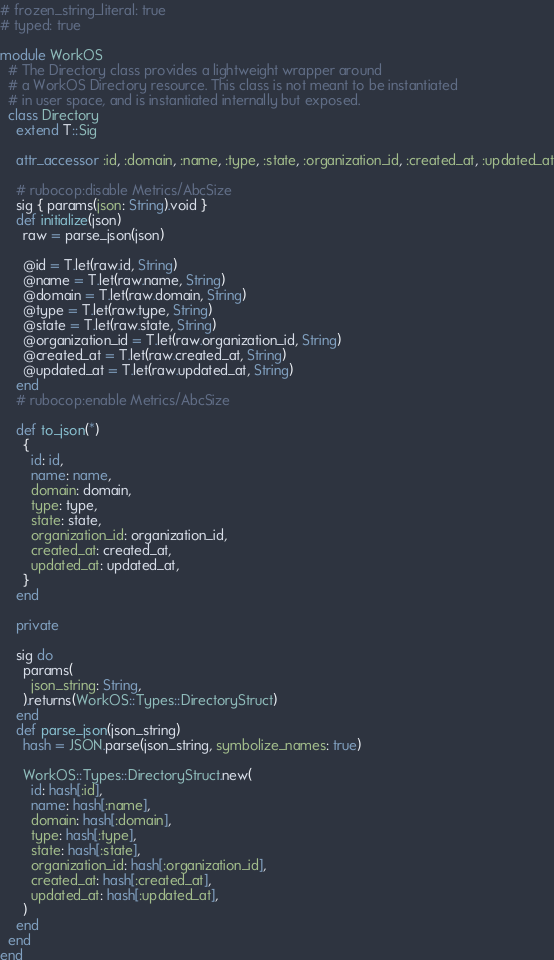Convert code to text. <code><loc_0><loc_0><loc_500><loc_500><_Ruby_># frozen_string_literal: true
# typed: true

module WorkOS
  # The Directory class provides a lightweight wrapper around
  # a WorkOS Directory resource. This class is not meant to be instantiated
  # in user space, and is instantiated internally but exposed.
  class Directory
    extend T::Sig

    attr_accessor :id, :domain, :name, :type, :state, :organization_id, :created_at, :updated_at

    # rubocop:disable Metrics/AbcSize
    sig { params(json: String).void }
    def initialize(json)
      raw = parse_json(json)

      @id = T.let(raw.id, String)
      @name = T.let(raw.name, String)
      @domain = T.let(raw.domain, String)
      @type = T.let(raw.type, String)
      @state = T.let(raw.state, String)
      @organization_id = T.let(raw.organization_id, String)
      @created_at = T.let(raw.created_at, String)
      @updated_at = T.let(raw.updated_at, String)
    end
    # rubocop:enable Metrics/AbcSize

    def to_json(*)
      {
        id: id,
        name: name,
        domain: domain,
        type: type,
        state: state,
        organization_id: organization_id,
        created_at: created_at,
        updated_at: updated_at,
      }
    end

    private

    sig do
      params(
        json_string: String,
      ).returns(WorkOS::Types::DirectoryStruct)
    end
    def parse_json(json_string)
      hash = JSON.parse(json_string, symbolize_names: true)

      WorkOS::Types::DirectoryStruct.new(
        id: hash[:id],
        name: hash[:name],
        domain: hash[:domain],
        type: hash[:type],
        state: hash[:state],
        organization_id: hash[:organization_id],
        created_at: hash[:created_at],
        updated_at: hash[:updated_at],
      )
    end
  end
end
</code> 